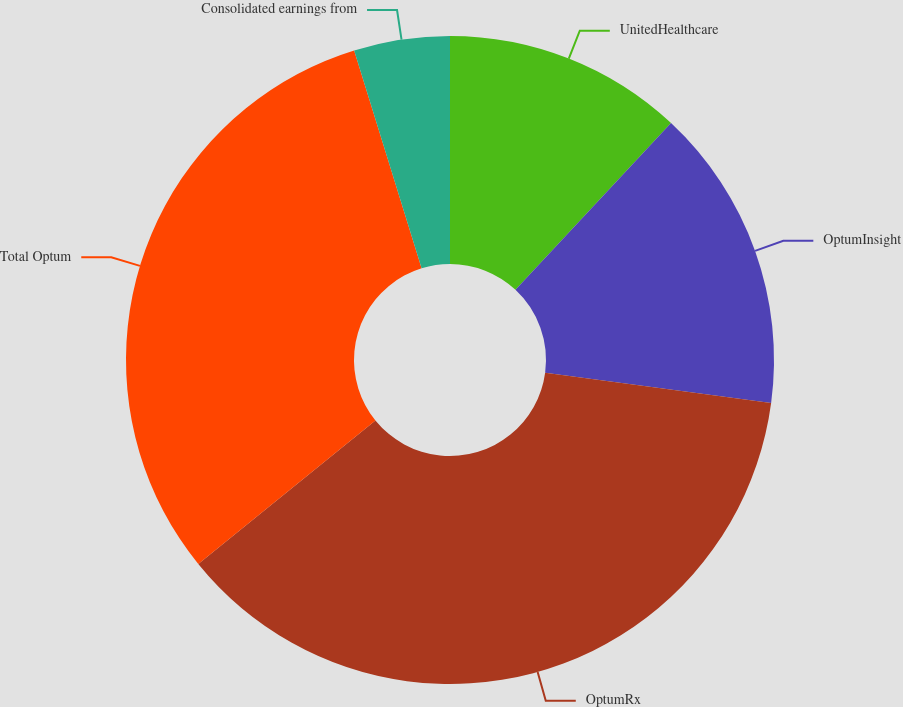<chart> <loc_0><loc_0><loc_500><loc_500><pie_chart><fcel>UnitedHealthcare<fcel>OptumInsight<fcel>OptumRx<fcel>Total Optum<fcel>Consolidated earnings from<nl><fcel>11.95%<fcel>15.17%<fcel>37.04%<fcel>31.06%<fcel>4.78%<nl></chart> 